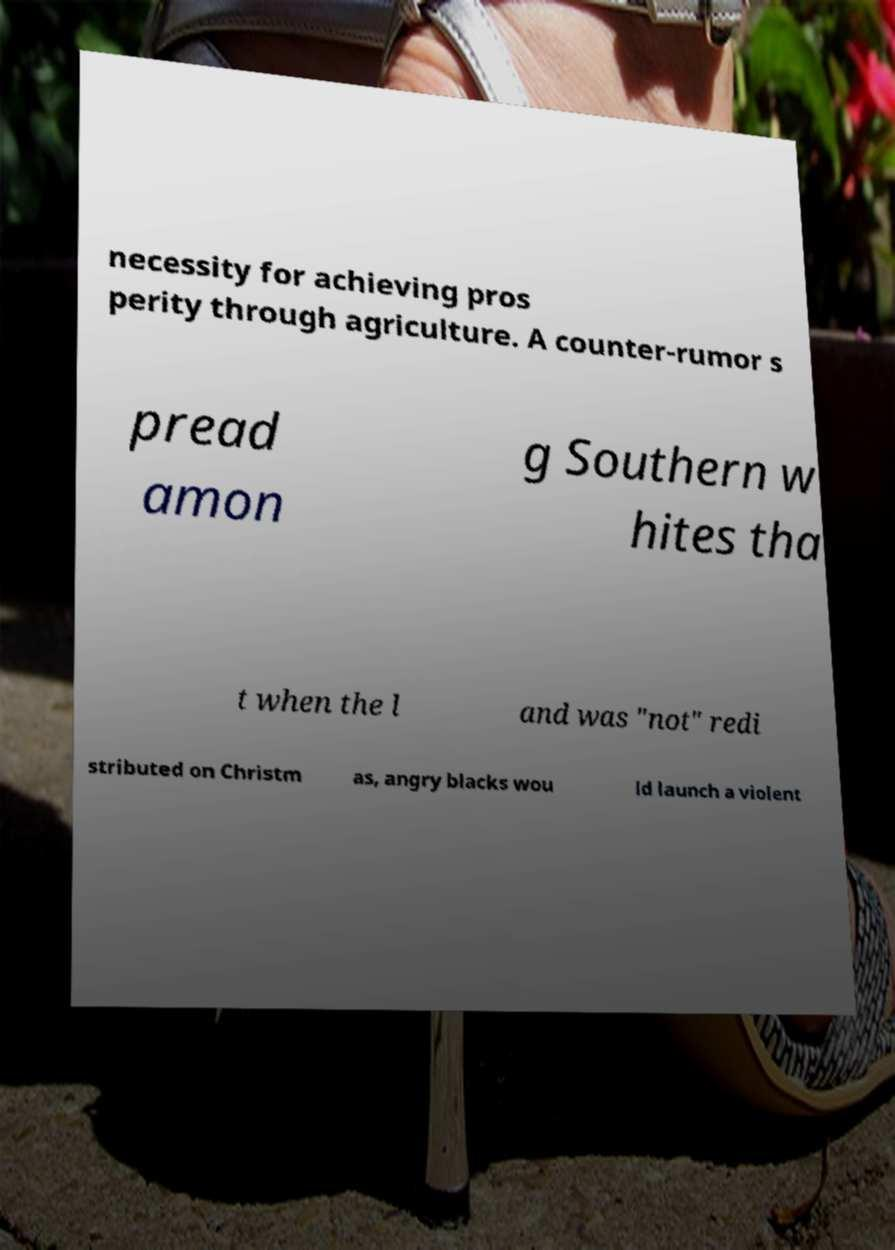I need the written content from this picture converted into text. Can you do that? necessity for achieving pros perity through agriculture. A counter-rumor s pread amon g Southern w hites tha t when the l and was "not" redi stributed on Christm as, angry blacks wou ld launch a violent 